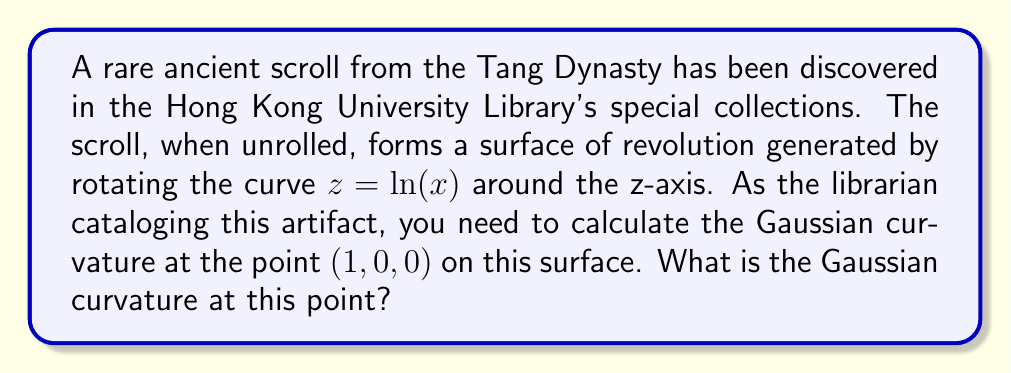Teach me how to tackle this problem. Let's approach this step-by-step:

1) For a surface of revolution generated by rotating $z = f(x)$ around the z-axis, we can parameterize it as:
   $r(u,v) = (u\cos v, u\sin v, f(u))$

2) In our case, $f(u) = \ln(u)$, so:
   $r(u,v) = (u\cos v, u\sin v, \ln(u))$

3) To calculate the Gaussian curvature, we need to find the coefficients of the first and second fundamental forms:

   $E = r_u \cdot r_u = 1 + (\frac{1}{u})^2$
   $F = r_u \cdot r_v = 0$
   $G = r_v \cdot r_v = u^2$

   $L = \frac{r_{uu} \cdot n}{|n|} = -\frac{1}{u\sqrt{1+(\frac{1}{u})^2}}$
   $M = \frac{r_{uv} \cdot n}{|n|} = 0$
   $N = \frac{r_{vv} \cdot n}{|n|} = \frac{u}{\sqrt{1+(\frac{1}{u})^2}}$

4) The Gaussian curvature is given by:
   $K = \frac{LN - M^2}{EG - F^2}$

5) Substituting our values:
   $K = \frac{(-\frac{1}{u\sqrt{1+(\frac{1}{u})^2}})(\frac{u}{\sqrt{1+(\frac{1}{u})^2}}) - 0^2}{(1 + (\frac{1}{u})^2)(u^2) - 0^2}$

6) Simplifying:
   $K = -\frac{1}{u^2(1+(\frac{1}{u})^2)^2}$

7) At the point $(1, 0, 0)$, $u = 1$, so:
   $K = -\frac{1}{1(1+1^2)^2} = -\frac{1}{4}$

Therefore, the Gaussian curvature at the point $(1, 0, 0)$ is $-\frac{1}{4}$.
Answer: $-\frac{1}{4}$ 